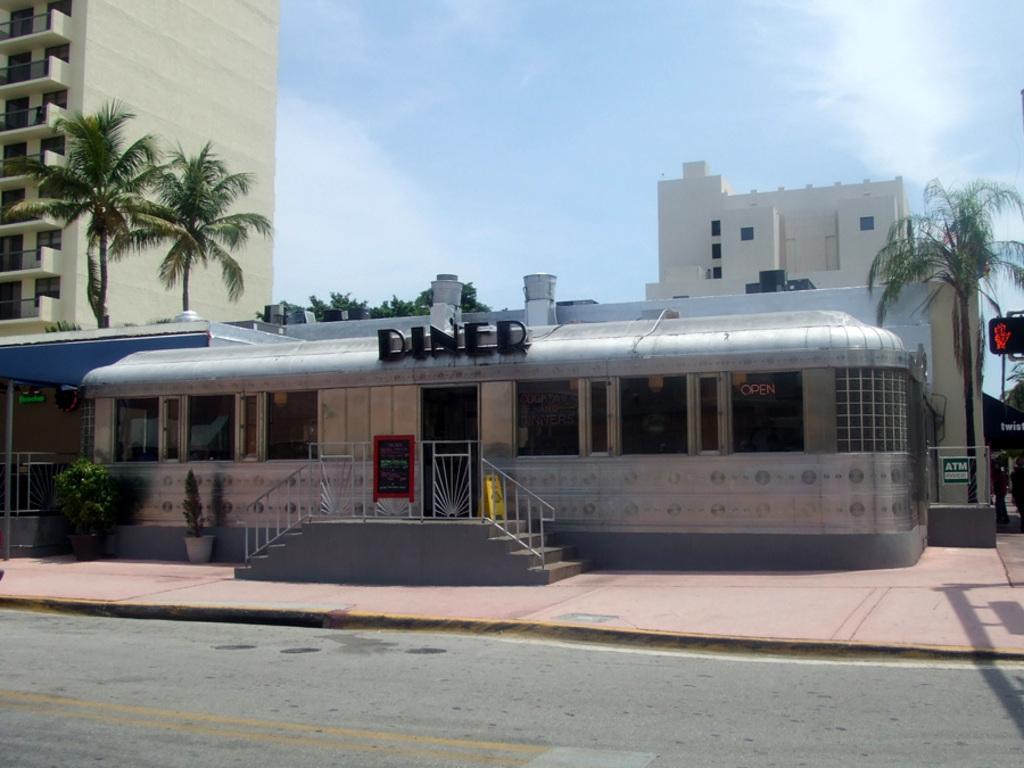What type of structures can be seen in the image? There are buildings in the image. Can you describe any architectural features in the image? Yes, there are stairs and a fence visible in the image. What type of text is present in the image? There is text in the image, but its content is not specified. What type of vegetation can be seen in the image? There are trees and plants in the image. What type of pathway is visible in the image? There is a road in the image. What is the color of the sky in the image? The sky is pale blue in the image. Can you tell me how many fangs are visible on the plants in the image? There are no fangs present on the plants in the image; they are not carnivorous plants. What type of growth is being promoted by the text in the image? The content of the text is not specified, so it is impossible to determine what type of growth it might be promoting. 